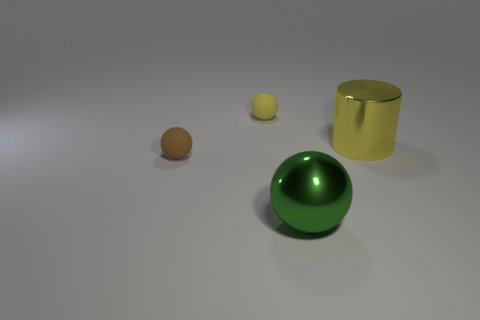Subtract all brown rubber balls. How many balls are left? 2 Add 2 small balls. How many objects exist? 6 Subtract all spheres. How many objects are left? 1 Subtract 1 cylinders. How many cylinders are left? 0 Subtract all yellow balls. How many balls are left? 2 Subtract all yellow spheres. Subtract all green cylinders. How many spheres are left? 2 Subtract all brown objects. Subtract all green metal objects. How many objects are left? 2 Add 3 yellow metallic things. How many yellow metallic things are left? 4 Add 2 small green cylinders. How many small green cylinders exist? 2 Subtract 0 cyan cylinders. How many objects are left? 4 